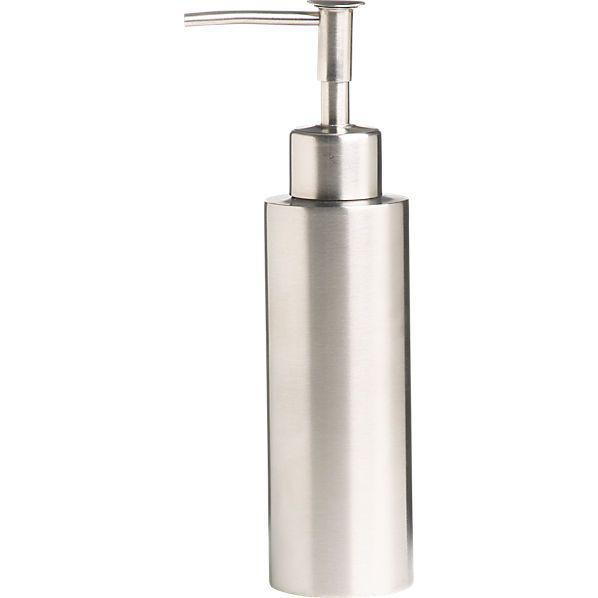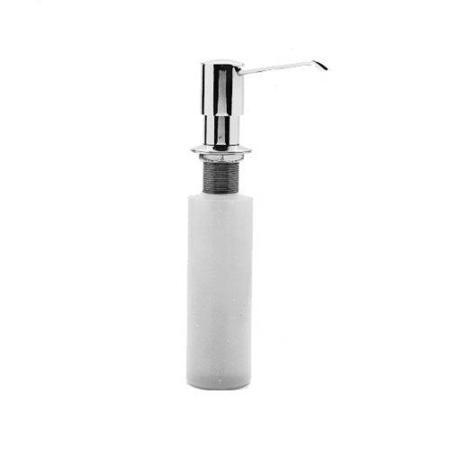The first image is the image on the left, the second image is the image on the right. For the images shown, is this caption "The nozzles of the dispensers in the left and right images face generally toward each other." true? Answer yes or no. No. The first image is the image on the left, the second image is the image on the right. Evaluate the accuracy of this statement regarding the images: "The dispenser in the right photo has a transparent bottle.". Is it true? Answer yes or no. No. 